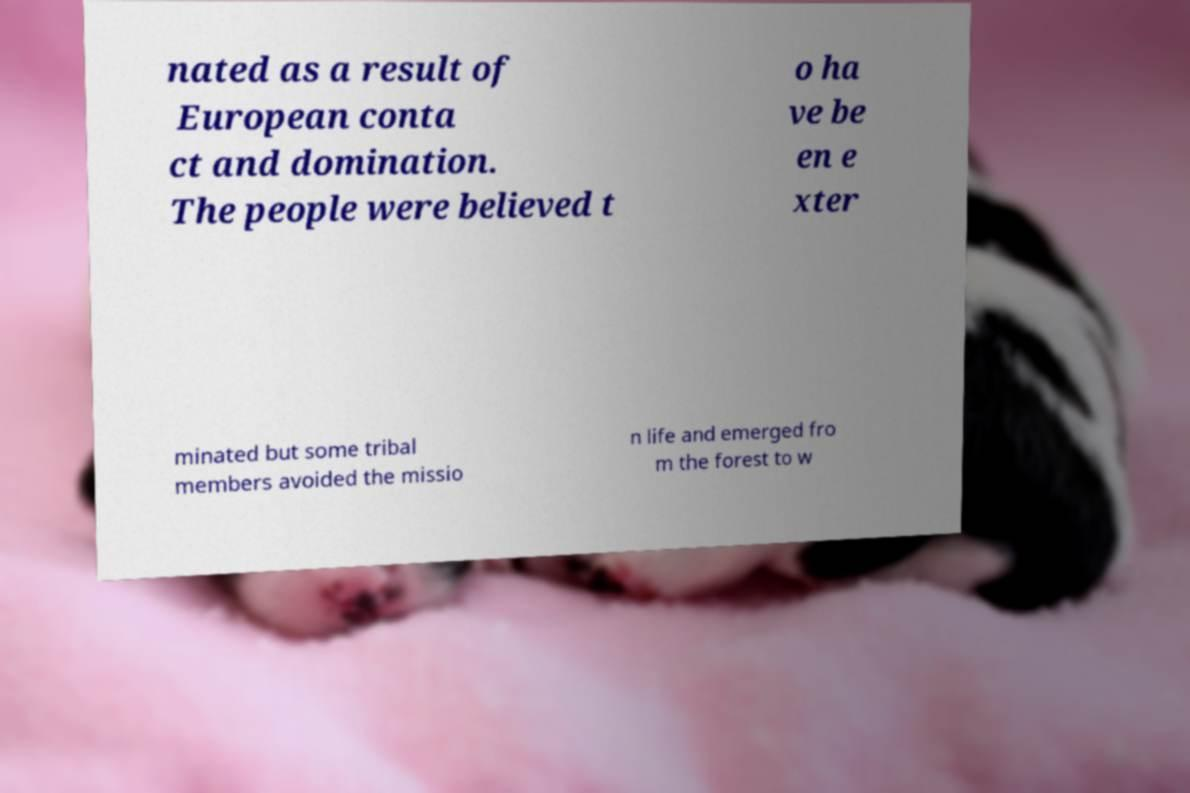Could you extract and type out the text from this image? nated as a result of European conta ct and domination. The people were believed t o ha ve be en e xter minated but some tribal members avoided the missio n life and emerged fro m the forest to w 